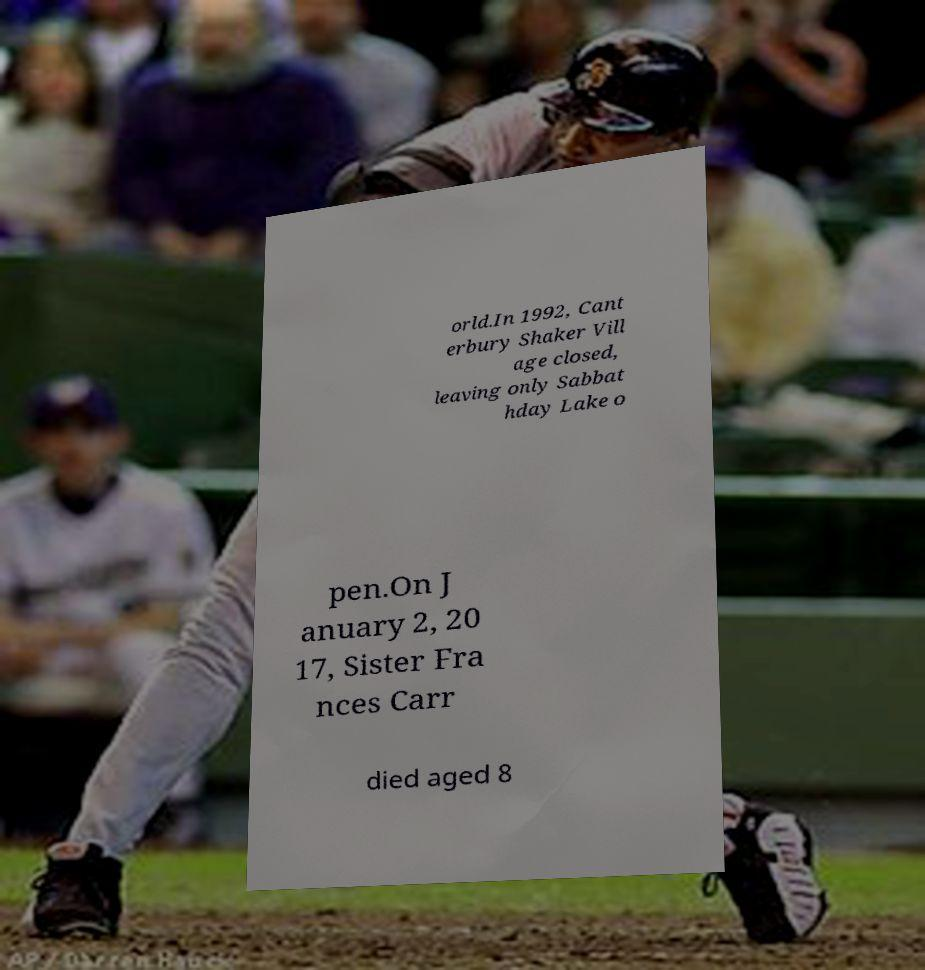What messages or text are displayed in this image? I need them in a readable, typed format. orld.In 1992, Cant erbury Shaker Vill age closed, leaving only Sabbat hday Lake o pen.On J anuary 2, 20 17, Sister Fra nces Carr died aged 8 